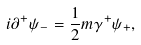Convert formula to latex. <formula><loc_0><loc_0><loc_500><loc_500>i \partial ^ { + } \psi _ { - } = \frac { 1 } { 2 } m \gamma ^ { + } \psi _ { + } ,</formula> 